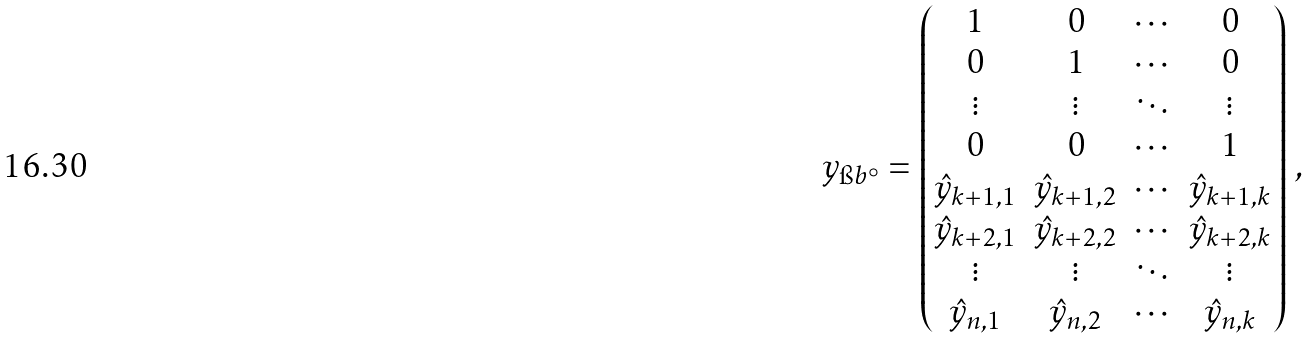<formula> <loc_0><loc_0><loc_500><loc_500>y _ { \i b ^ { \circ } } = \begin{pmatrix} 1 & 0 & \cdots & 0 \\ 0 & 1 & \cdots & 0 \\ \vdots & \vdots & \ddots & \vdots \\ 0 & 0 & \cdots & 1 \\ \hat { y } _ { k + 1 , 1 } & \hat { y } _ { k + 1 , 2 } & \cdots & \hat { y } _ { k + 1 , k } \\ \hat { y } _ { k + 2 , 1 } & \hat { y } _ { k + 2 , 2 } & \cdots & \hat { y } _ { k + 2 , k } \\ \vdots & \vdots & \ddots & \vdots \\ \hat { y } _ { n , 1 } & \hat { y } _ { n , 2 } & \cdots & \hat { y } _ { n , k } \end{pmatrix} \, ,</formula> 